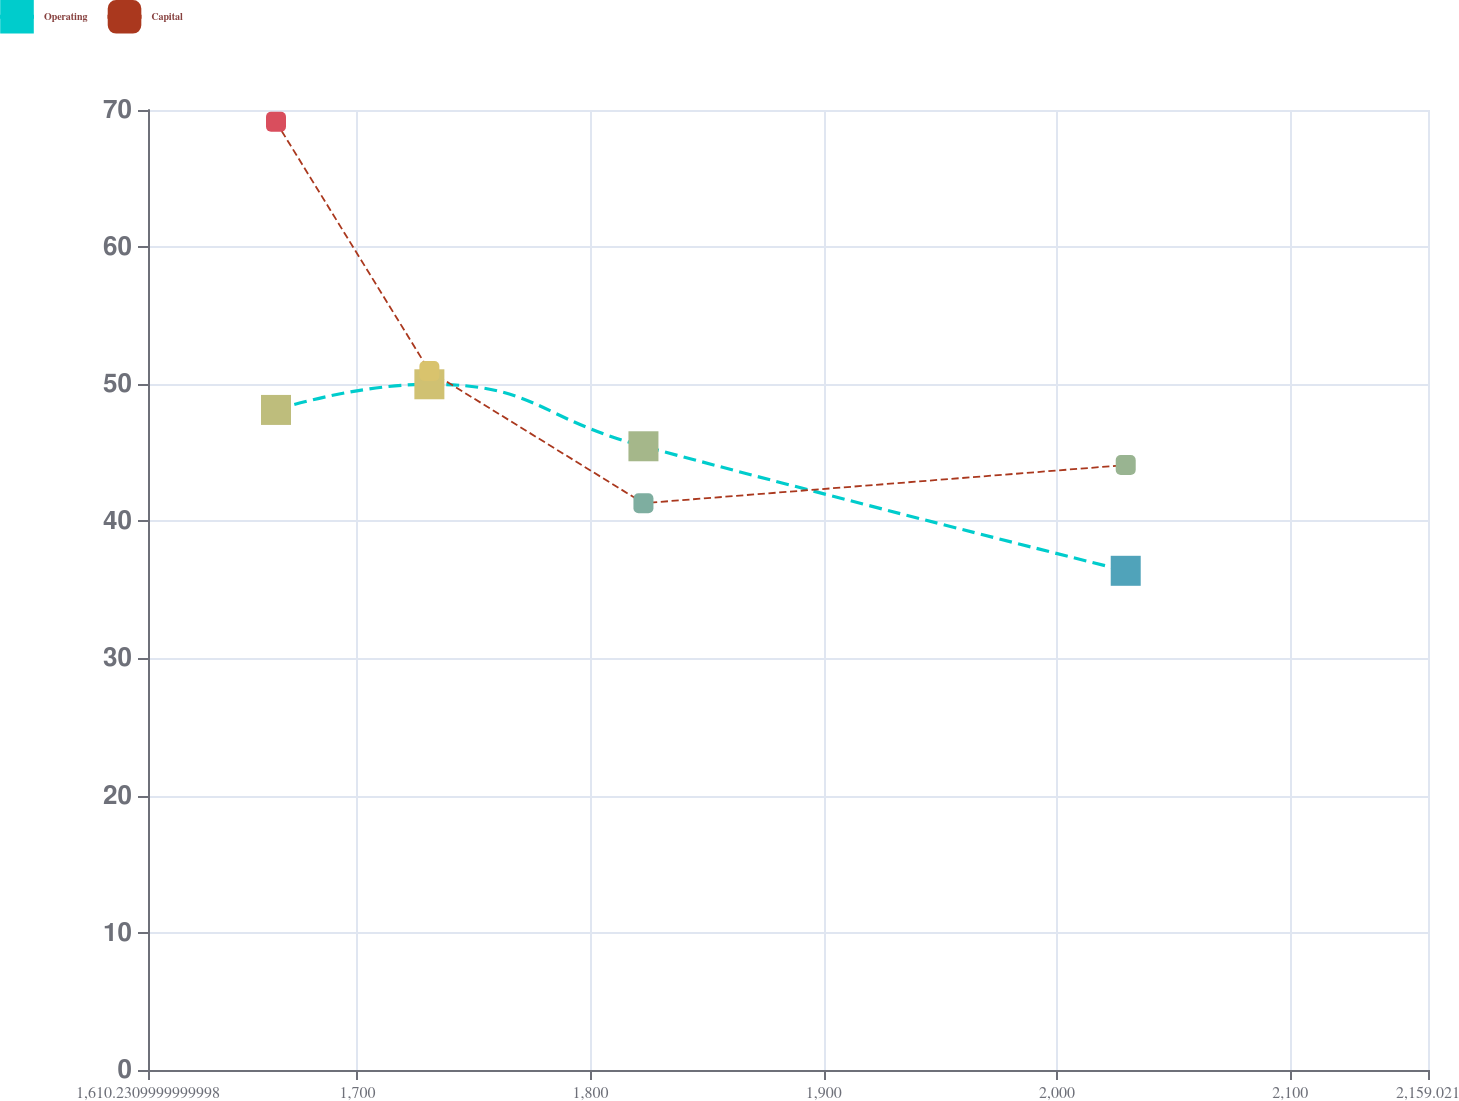Convert chart. <chart><loc_0><loc_0><loc_500><loc_500><line_chart><ecel><fcel>Operating<fcel>Capital<nl><fcel>1665.11<fcel>48.13<fcel>69.14<nl><fcel>1730.87<fcel>50<fcel>50.97<nl><fcel>1822.65<fcel>45.48<fcel>41.33<nl><fcel>2029.42<fcel>36.4<fcel>44.11<nl><fcel>2213.9<fcel>38.54<fcel>46.89<nl></chart> 